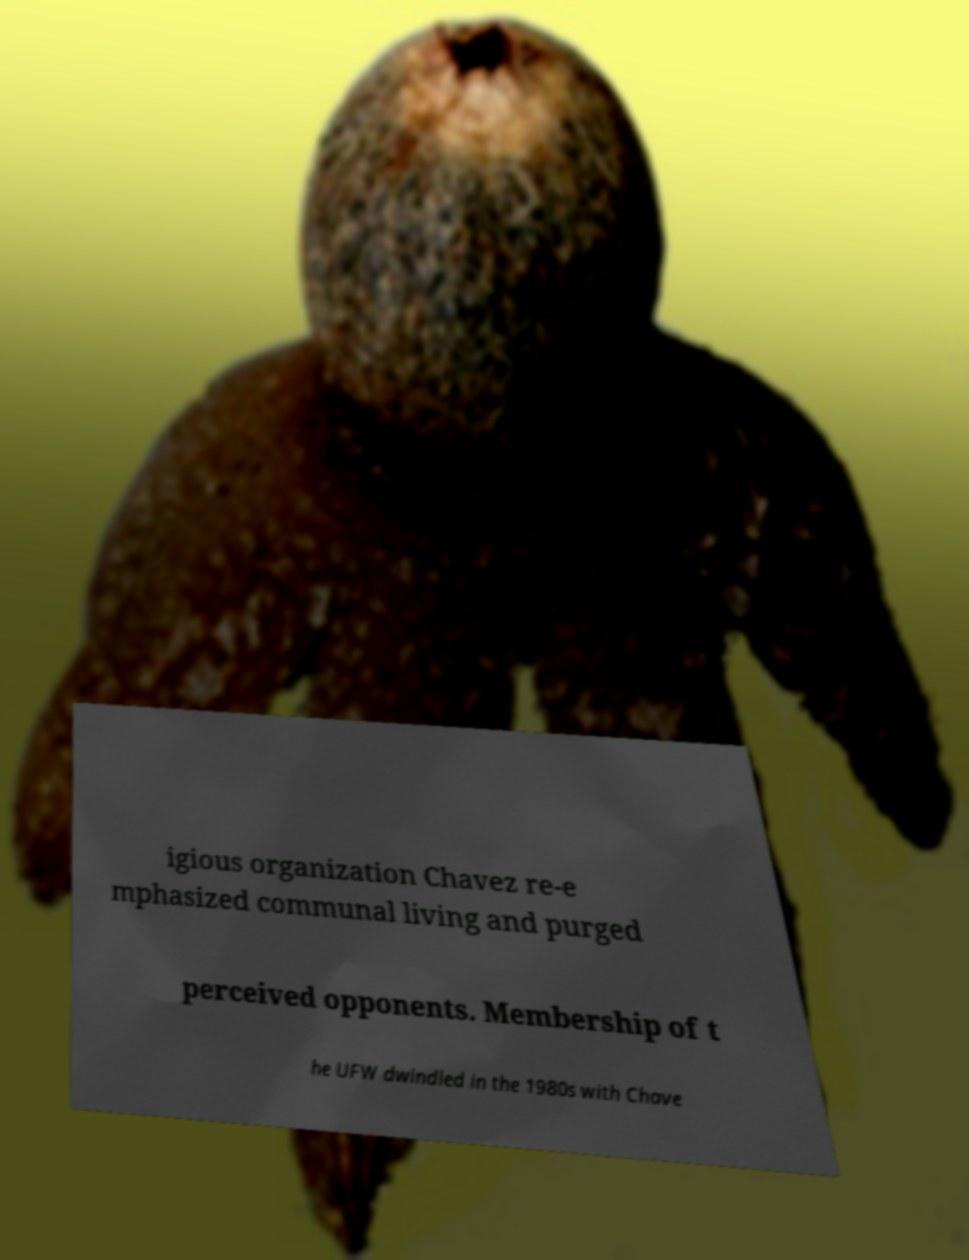What messages or text are displayed in this image? I need them in a readable, typed format. igious organization Chavez re-e mphasized communal living and purged perceived opponents. Membership of t he UFW dwindled in the 1980s with Chave 